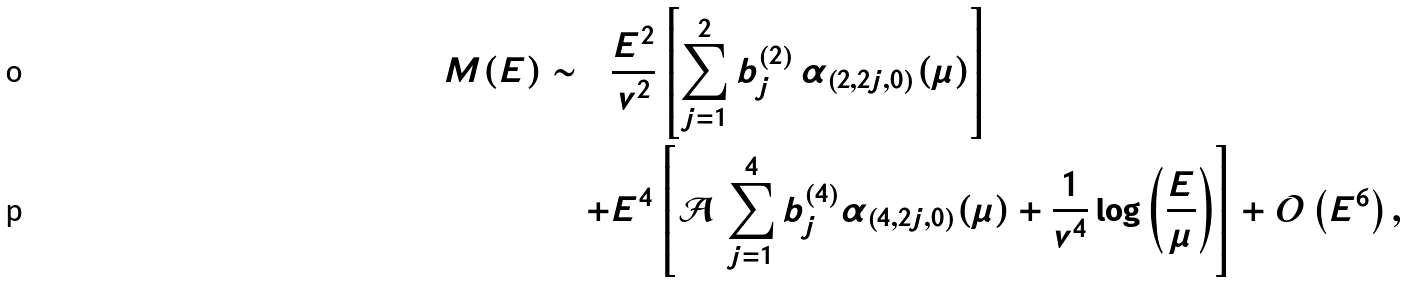Convert formula to latex. <formula><loc_0><loc_0><loc_500><loc_500>M ( E ) \sim \quad & \frac { E ^ { 2 } } { v ^ { 2 } } \left [ \sum _ { j = 1 } ^ { 2 } b ^ { ( 2 ) } _ { j } \, \alpha _ { ( 2 , 2 j , 0 ) } ( \mu ) \right ] \\ + & E ^ { 4 } \left [ \mathcal { A } \, \sum _ { j = 1 } ^ { 4 } b ^ { ( 4 ) } _ { j } \alpha _ { ( 4 , 2 j , 0 ) } ( \mu ) + \frac { 1 } { v ^ { 4 } } \log { \left ( \frac { E } { \mu } \right ) } \right ] + \mathcal { O } \left ( E ^ { 6 } \right ) ,</formula> 